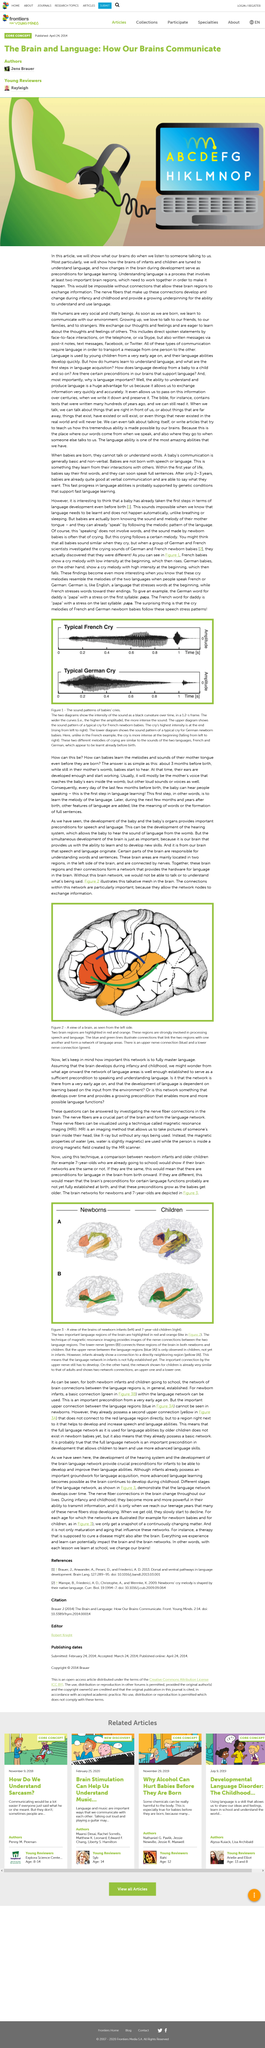Indicate a few pertinent items in this graphic. The time frame of the diagram is 1.2 seconds. The formation of language networks in the brain is primarily driven by nerve diversity. MRI is a diagnostic imaging technique that produces detailed images of the internal structures of the human brain by using a strong magnetic field, radio waves, and a computer to produce detailed images of the brain. The image depicts a representation of the brain from the left side, which serves as a visual representation of the brain's structure and function. French and German newborn babies follow specific speech stress patterns that are characteristic of their respective languages. 